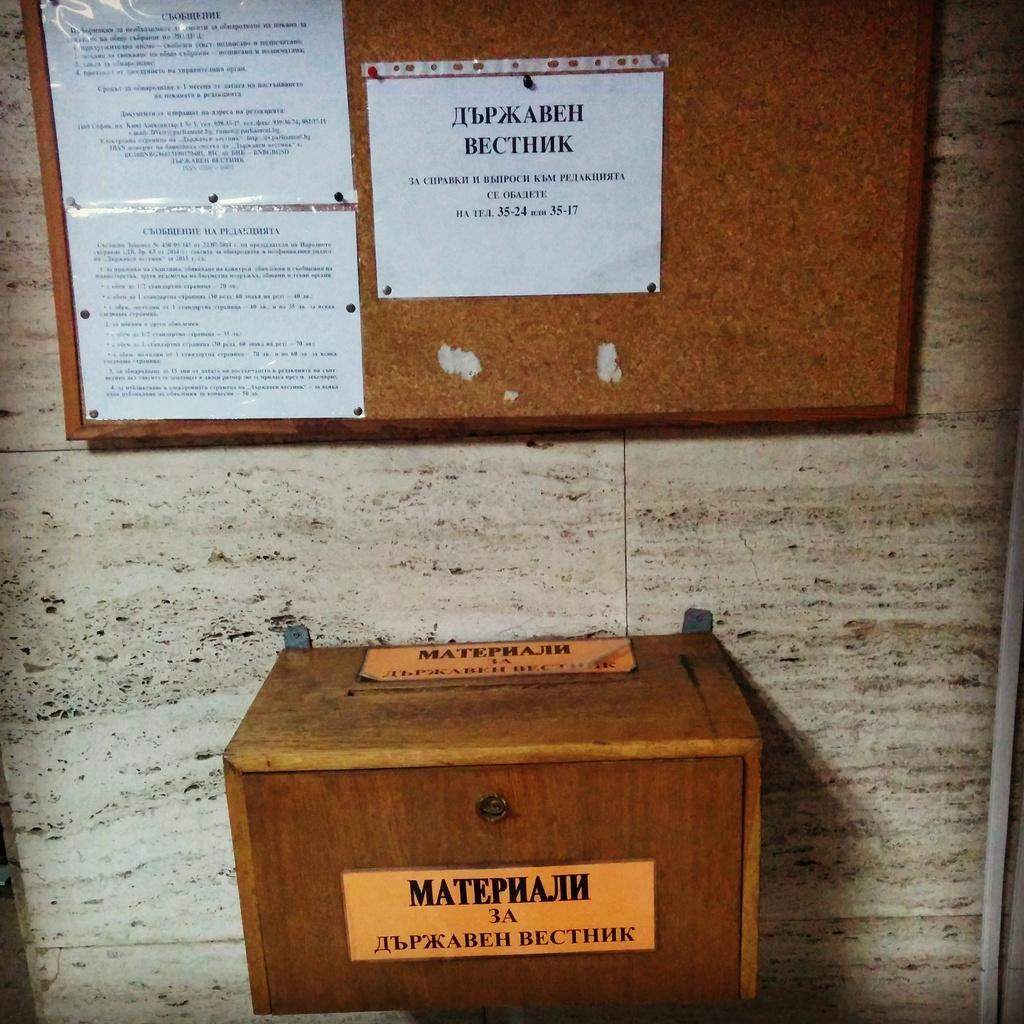<image>
Relay a brief, clear account of the picture shown. A wood item has stickers on it that contain the word "matephajin". 